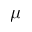<formula> <loc_0><loc_0><loc_500><loc_500>\mu</formula> 